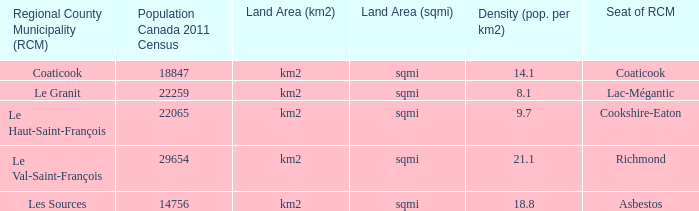What is the seat of the RCM in the county that has a density of 9.7? Cookshire-Eaton. 